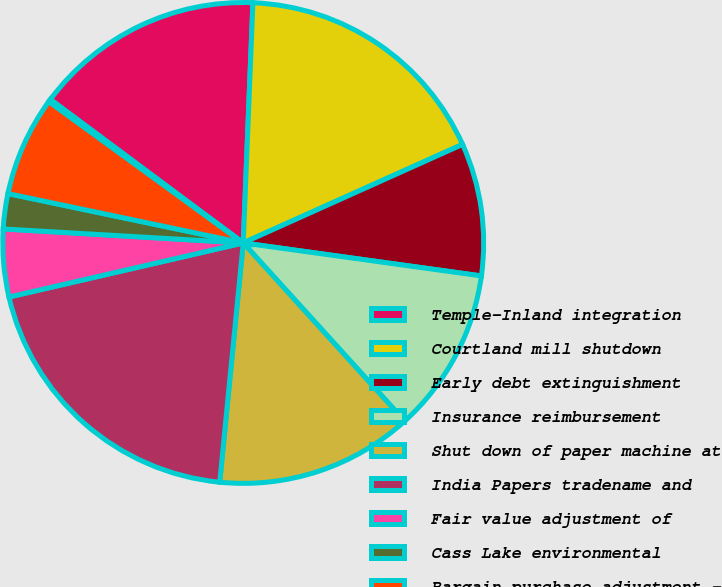Convert chart. <chart><loc_0><loc_0><loc_500><loc_500><pie_chart><fcel>Temple-Inland integration<fcel>Courtland mill shutdown<fcel>Early debt extinguishment<fcel>Insurance reimbursement<fcel>Shut down of paper machine at<fcel>India Papers tradename and<fcel>Fair value adjustment of<fcel>Cass Lake environmental<fcel>Bargain purchase adjustment -<fcel>Other items<nl><fcel>15.46%<fcel>17.64%<fcel>8.91%<fcel>11.09%<fcel>13.28%<fcel>19.83%<fcel>4.54%<fcel>2.36%<fcel>6.72%<fcel>0.17%<nl></chart> 